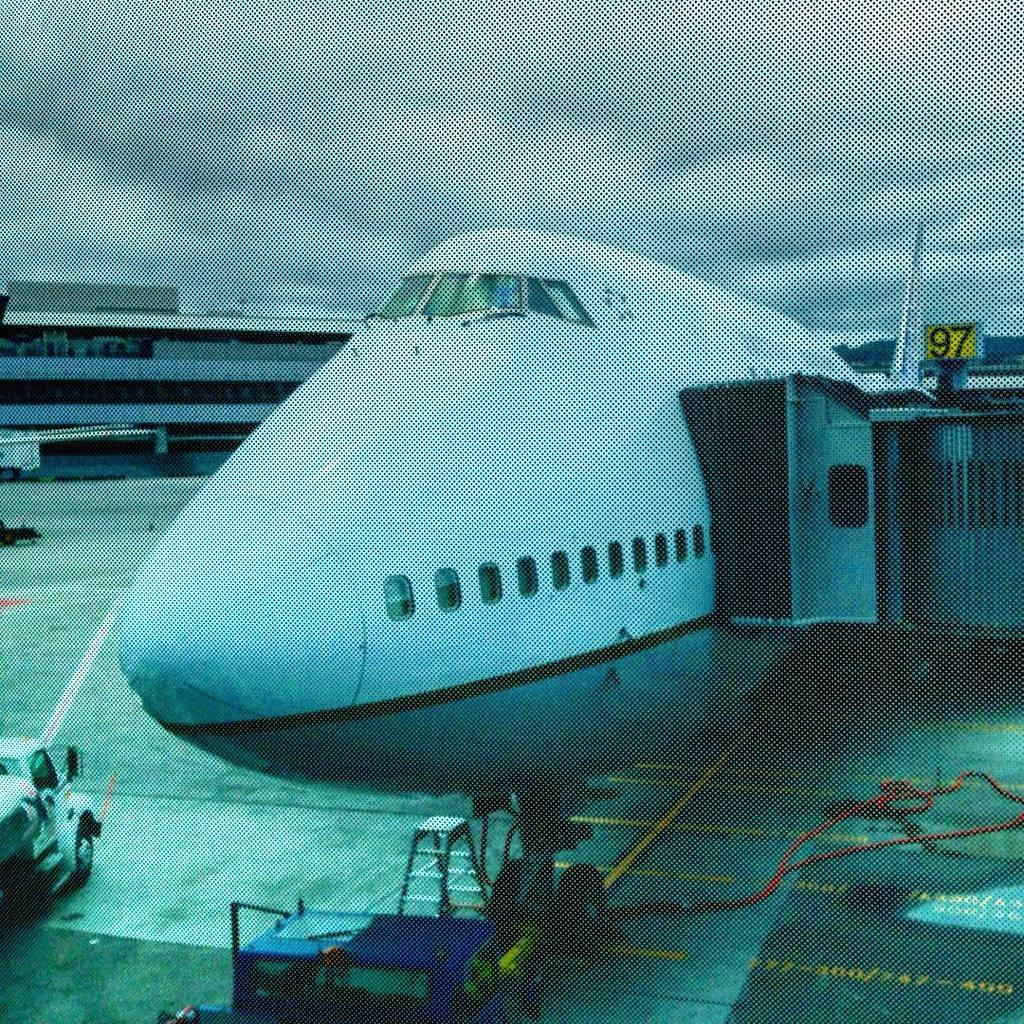<image>
Offer a succinct explanation of the picture presented. White airplane parked with a yellow sign that says 97. 